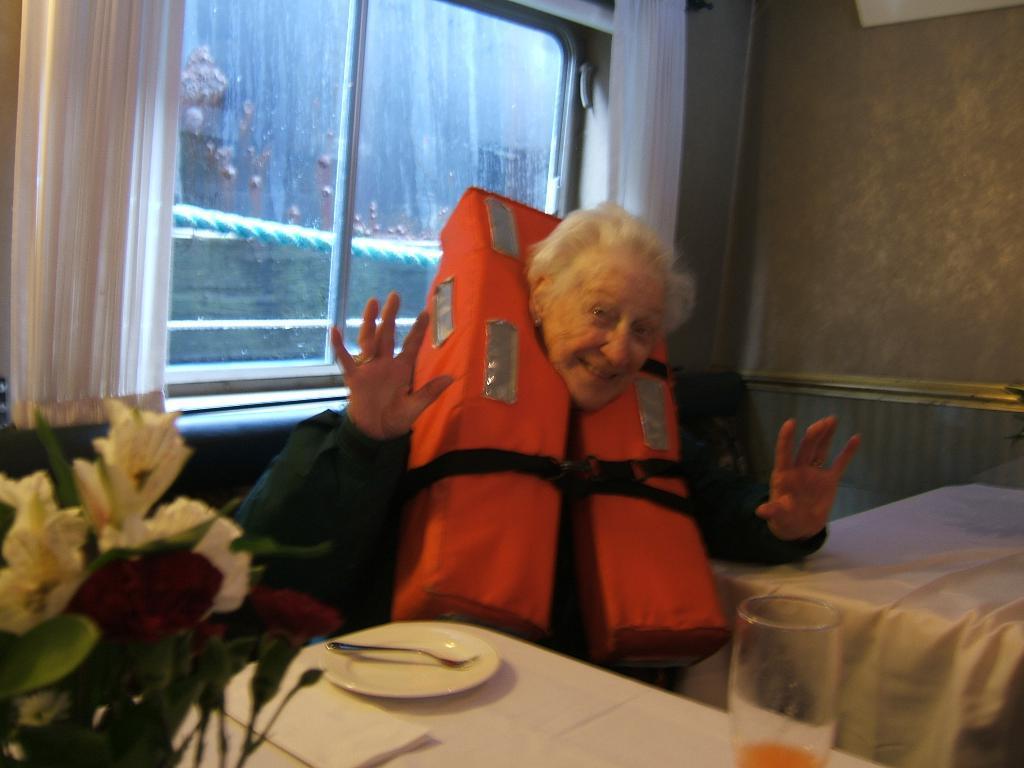Could you give a brief overview of what you see in this image? A old woman is sitting in the sofa and behind her there is a glass window. 